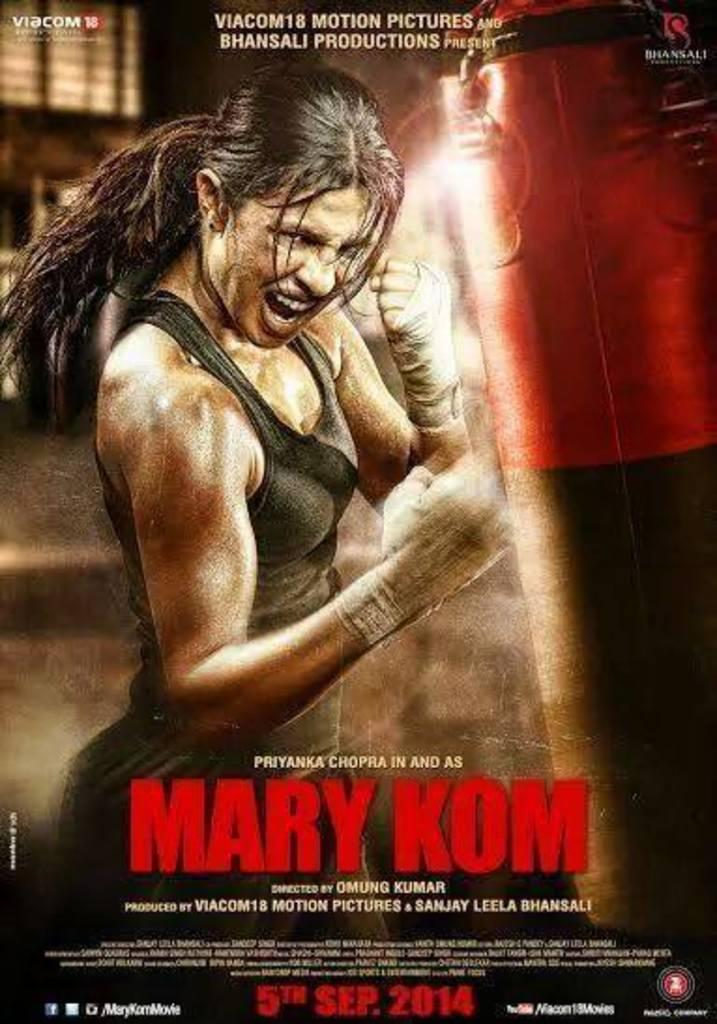Provide a one-sentence caption for the provided image. A movie poster with a girl in an angry fighting pose and has the words Mary Kom across it. 